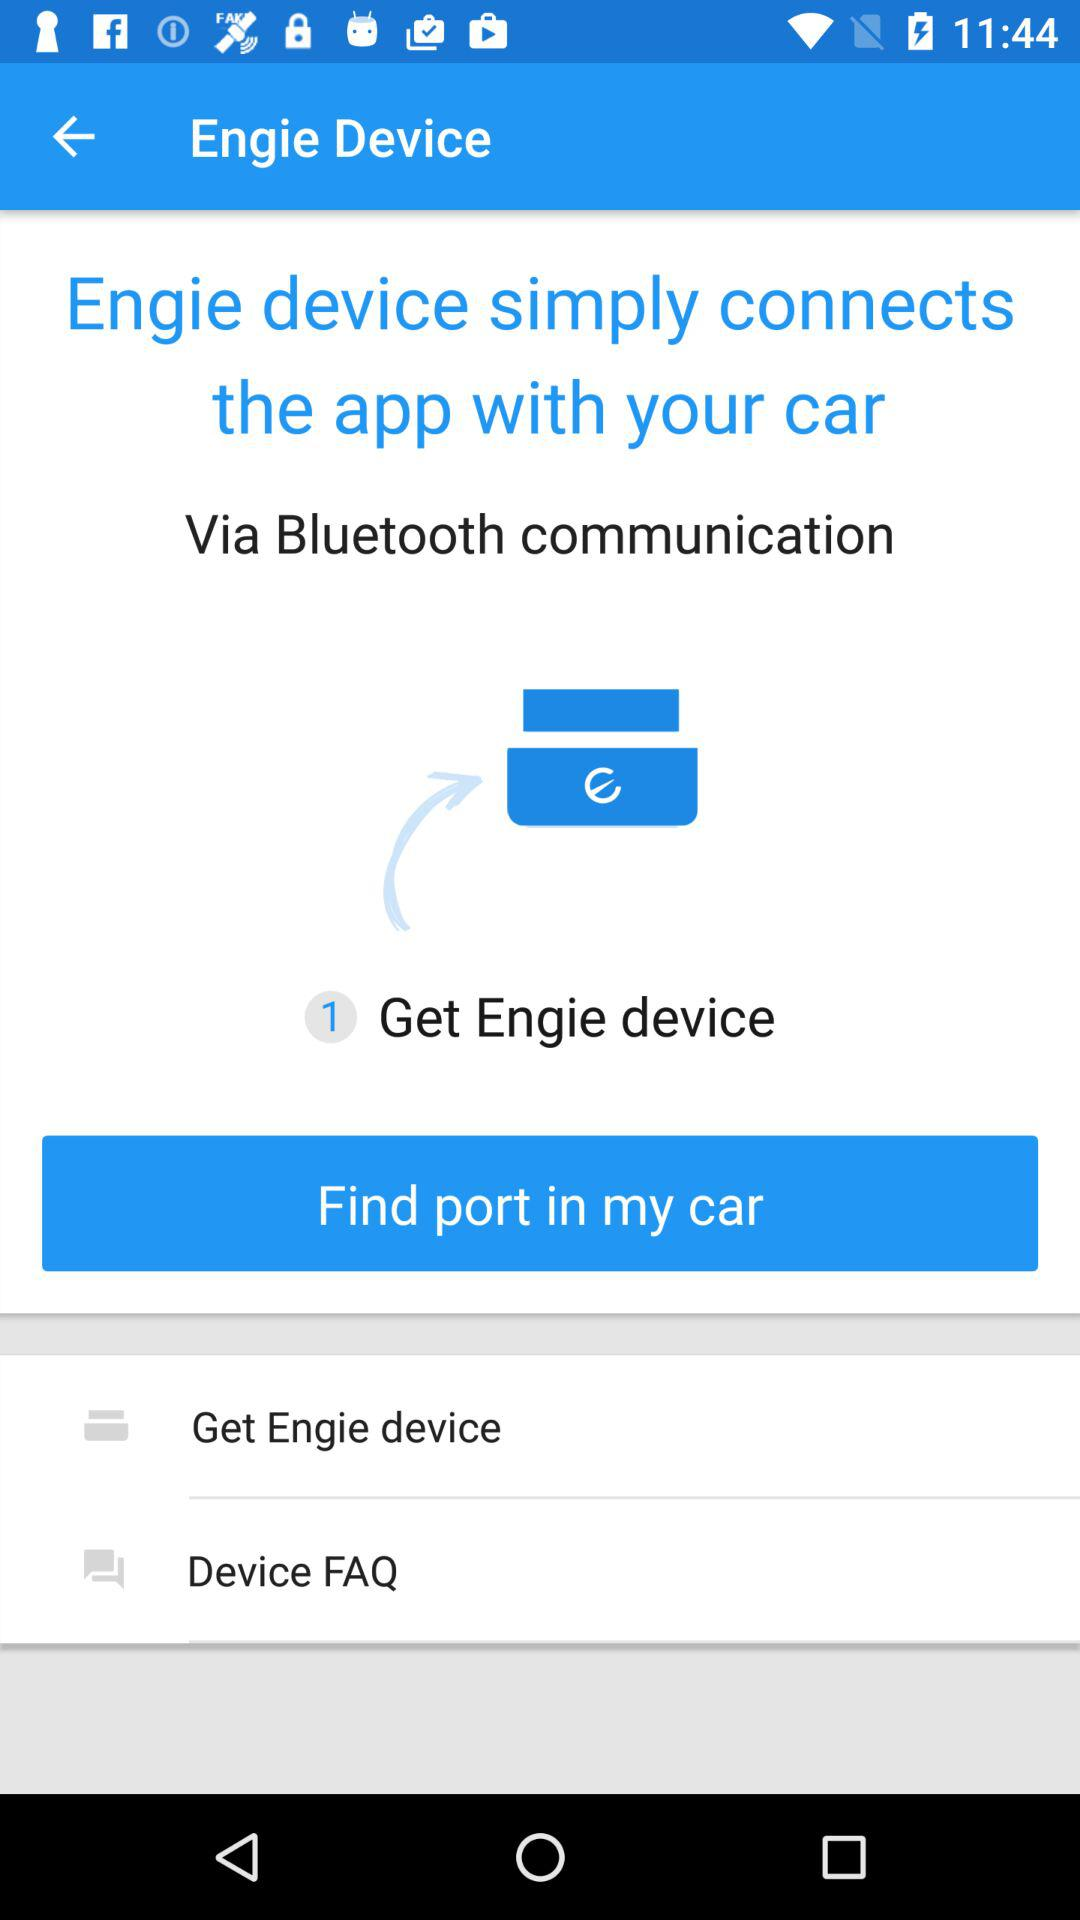What things does the Engie device connect? The Engie device connects the app with your car. 